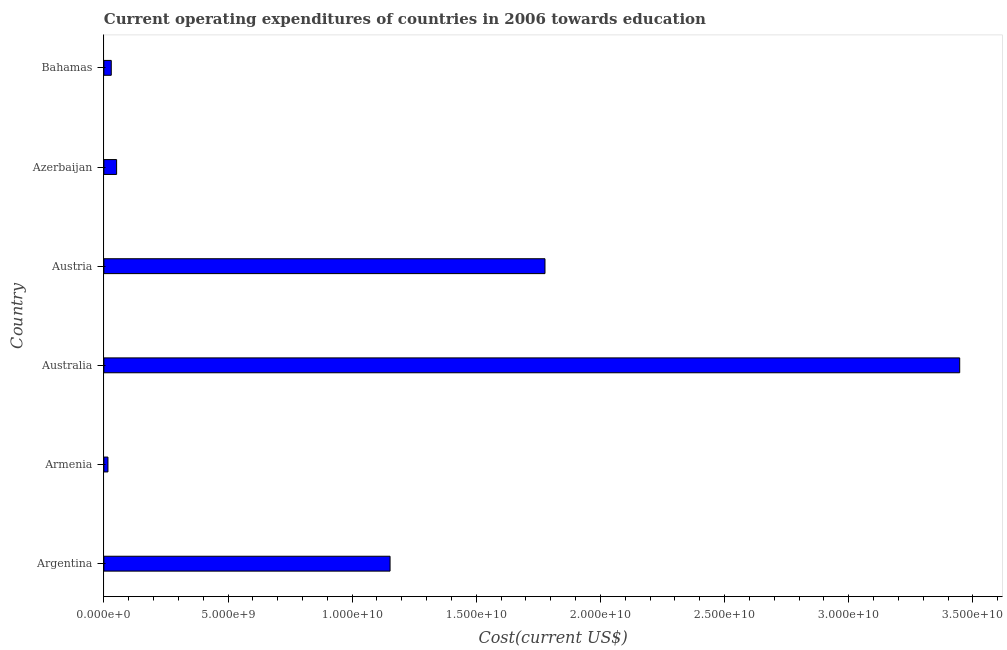What is the title of the graph?
Give a very brief answer. Current operating expenditures of countries in 2006 towards education. What is the label or title of the X-axis?
Provide a succinct answer. Cost(current US$). What is the education expenditure in Bahamas?
Offer a terse response. 2.97e+08. Across all countries, what is the maximum education expenditure?
Offer a very short reply. 3.45e+1. Across all countries, what is the minimum education expenditure?
Offer a terse response. 1.64e+08. In which country was the education expenditure maximum?
Your response must be concise. Australia. In which country was the education expenditure minimum?
Give a very brief answer. Armenia. What is the sum of the education expenditure?
Provide a short and direct response. 6.47e+1. What is the difference between the education expenditure in Austria and Bahamas?
Provide a short and direct response. 1.75e+1. What is the average education expenditure per country?
Offer a terse response. 1.08e+1. What is the median education expenditure?
Make the answer very short. 6.02e+09. In how many countries, is the education expenditure greater than 2000000000 US$?
Make the answer very short. 3. What is the ratio of the education expenditure in Armenia to that in Austria?
Provide a short and direct response. 0.01. What is the difference between the highest and the second highest education expenditure?
Give a very brief answer. 1.67e+1. What is the difference between the highest and the lowest education expenditure?
Provide a short and direct response. 3.43e+1. In how many countries, is the education expenditure greater than the average education expenditure taken over all countries?
Make the answer very short. 3. How many bars are there?
Provide a short and direct response. 6. Are all the bars in the graph horizontal?
Keep it short and to the point. Yes. How many countries are there in the graph?
Your answer should be very brief. 6. What is the difference between two consecutive major ticks on the X-axis?
Ensure brevity in your answer.  5.00e+09. What is the Cost(current US$) of Argentina?
Offer a terse response. 1.15e+1. What is the Cost(current US$) of Armenia?
Provide a short and direct response. 1.64e+08. What is the Cost(current US$) in Australia?
Give a very brief answer. 3.45e+1. What is the Cost(current US$) in Austria?
Provide a short and direct response. 1.78e+1. What is the Cost(current US$) in Azerbaijan?
Your response must be concise. 5.12e+08. What is the Cost(current US$) in Bahamas?
Provide a short and direct response. 2.97e+08. What is the difference between the Cost(current US$) in Argentina and Armenia?
Make the answer very short. 1.14e+1. What is the difference between the Cost(current US$) in Argentina and Australia?
Ensure brevity in your answer.  -2.29e+1. What is the difference between the Cost(current US$) in Argentina and Austria?
Provide a short and direct response. -6.24e+09. What is the difference between the Cost(current US$) in Argentina and Azerbaijan?
Provide a succinct answer. 1.10e+1. What is the difference between the Cost(current US$) in Argentina and Bahamas?
Your answer should be very brief. 1.12e+1. What is the difference between the Cost(current US$) in Armenia and Australia?
Provide a succinct answer. -3.43e+1. What is the difference between the Cost(current US$) in Armenia and Austria?
Ensure brevity in your answer.  -1.76e+1. What is the difference between the Cost(current US$) in Armenia and Azerbaijan?
Your answer should be very brief. -3.49e+08. What is the difference between the Cost(current US$) in Armenia and Bahamas?
Provide a short and direct response. -1.33e+08. What is the difference between the Cost(current US$) in Australia and Austria?
Provide a short and direct response. 1.67e+1. What is the difference between the Cost(current US$) in Australia and Azerbaijan?
Your answer should be compact. 3.40e+1. What is the difference between the Cost(current US$) in Australia and Bahamas?
Keep it short and to the point. 3.42e+1. What is the difference between the Cost(current US$) in Austria and Azerbaijan?
Make the answer very short. 1.73e+1. What is the difference between the Cost(current US$) in Austria and Bahamas?
Your answer should be very brief. 1.75e+1. What is the difference between the Cost(current US$) in Azerbaijan and Bahamas?
Provide a succinct answer. 2.15e+08. What is the ratio of the Cost(current US$) in Argentina to that in Armenia?
Offer a terse response. 70.36. What is the ratio of the Cost(current US$) in Argentina to that in Australia?
Give a very brief answer. 0.33. What is the ratio of the Cost(current US$) in Argentina to that in Austria?
Your answer should be compact. 0.65. What is the ratio of the Cost(current US$) in Argentina to that in Azerbaijan?
Offer a terse response. 22.49. What is the ratio of the Cost(current US$) in Argentina to that in Bahamas?
Give a very brief answer. 38.79. What is the ratio of the Cost(current US$) in Armenia to that in Australia?
Provide a succinct answer. 0.01. What is the ratio of the Cost(current US$) in Armenia to that in Austria?
Provide a succinct answer. 0.01. What is the ratio of the Cost(current US$) in Armenia to that in Azerbaijan?
Keep it short and to the point. 0.32. What is the ratio of the Cost(current US$) in Armenia to that in Bahamas?
Keep it short and to the point. 0.55. What is the ratio of the Cost(current US$) in Australia to that in Austria?
Your answer should be very brief. 1.94. What is the ratio of the Cost(current US$) in Australia to that in Azerbaijan?
Offer a very short reply. 67.27. What is the ratio of the Cost(current US$) in Australia to that in Bahamas?
Keep it short and to the point. 116. What is the ratio of the Cost(current US$) in Austria to that in Azerbaijan?
Your answer should be compact. 34.67. What is the ratio of the Cost(current US$) in Austria to that in Bahamas?
Offer a terse response. 59.79. What is the ratio of the Cost(current US$) in Azerbaijan to that in Bahamas?
Offer a very short reply. 1.73. 